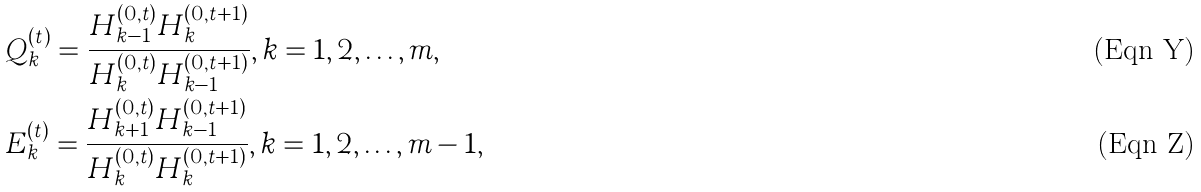Convert formula to latex. <formula><loc_0><loc_0><loc_500><loc_500>& Q _ { k } ^ { ( t ) } = \frac { H _ { k - 1 } ^ { ( 0 , t ) } H _ { k } ^ { ( 0 , t + 1 ) } } { H _ { k } ^ { ( 0 , t ) } H _ { k - 1 } ^ { ( 0 , t + 1 ) } } , k = 1 , 2 , \dots , m , \\ & E _ { k } ^ { ( t ) } = \frac { H _ { k + 1 } ^ { ( 0 , t ) } H _ { k - 1 } ^ { ( 0 , t + 1 ) } } { H _ { k } ^ { ( 0 , t ) } H _ { k } ^ { ( 0 , t + 1 ) } } , k = 1 , 2 , \dots , m - 1 ,</formula> 